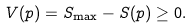<formula> <loc_0><loc_0><loc_500><loc_500>V ( p ) = S _ { \max } - S ( p ) \geq 0 .</formula> 